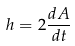<formula> <loc_0><loc_0><loc_500><loc_500>h = 2 \frac { d A } { d t }</formula> 